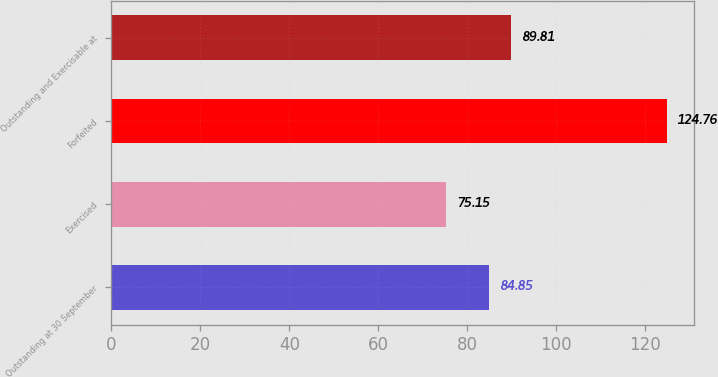<chart> <loc_0><loc_0><loc_500><loc_500><bar_chart><fcel>Outstanding at 30 September<fcel>Exercised<fcel>Forfeited<fcel>Outstanding and Exercisable at<nl><fcel>84.85<fcel>75.15<fcel>124.76<fcel>89.81<nl></chart> 